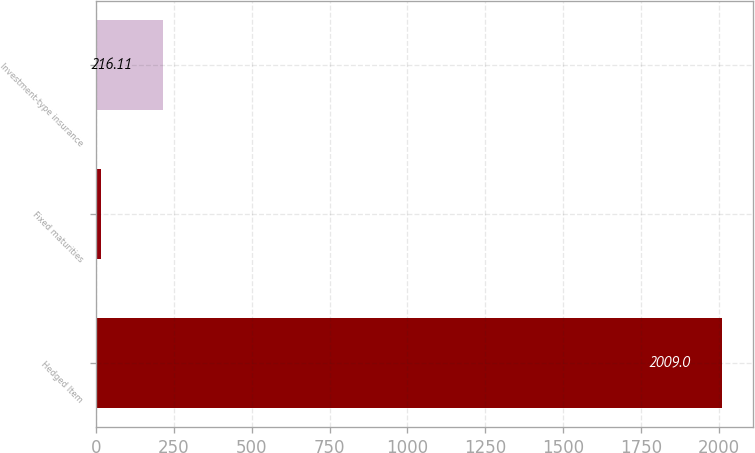Convert chart. <chart><loc_0><loc_0><loc_500><loc_500><bar_chart><fcel>Hedged Item<fcel>Fixed maturities<fcel>Investment-type insurance<nl><fcel>2009<fcel>16.9<fcel>216.11<nl></chart> 